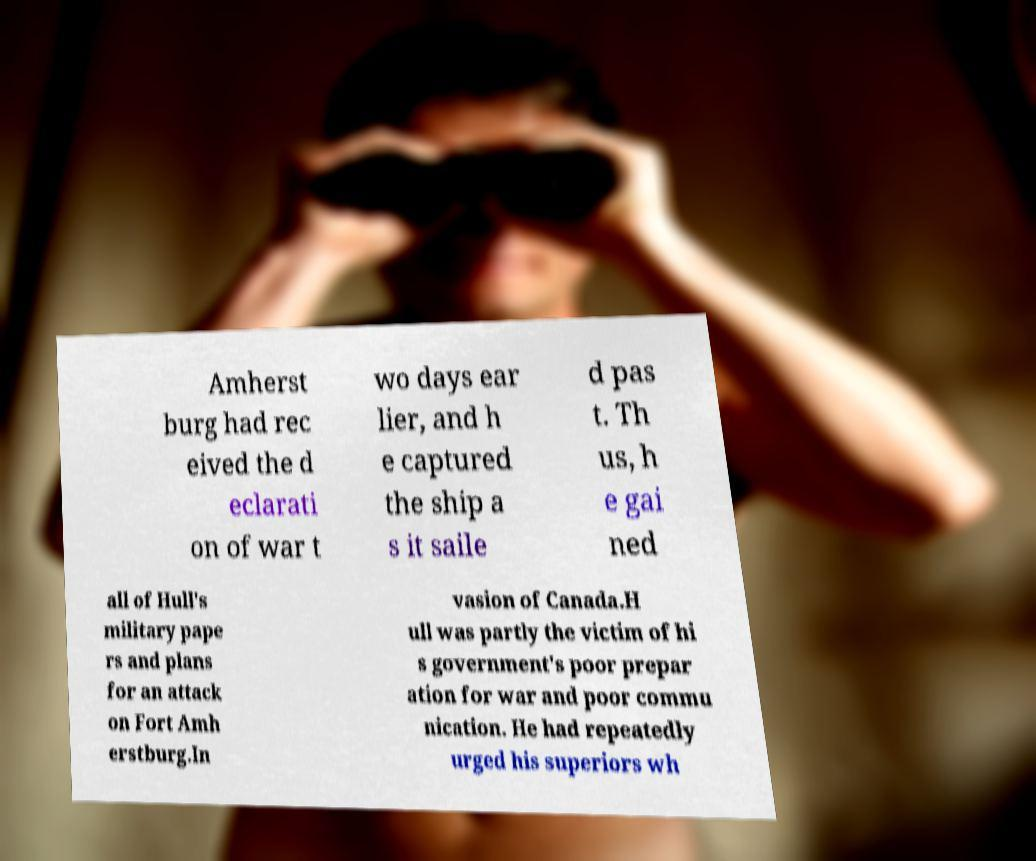There's text embedded in this image that I need extracted. Can you transcribe it verbatim? Amherst burg had rec eived the d eclarati on of war t wo days ear lier, and h e captured the ship a s it saile d pas t. Th us, h e gai ned all of Hull's military pape rs and plans for an attack on Fort Amh erstburg.In vasion of Canada.H ull was partly the victim of hi s government's poor prepar ation for war and poor commu nication. He had repeatedly urged his superiors wh 